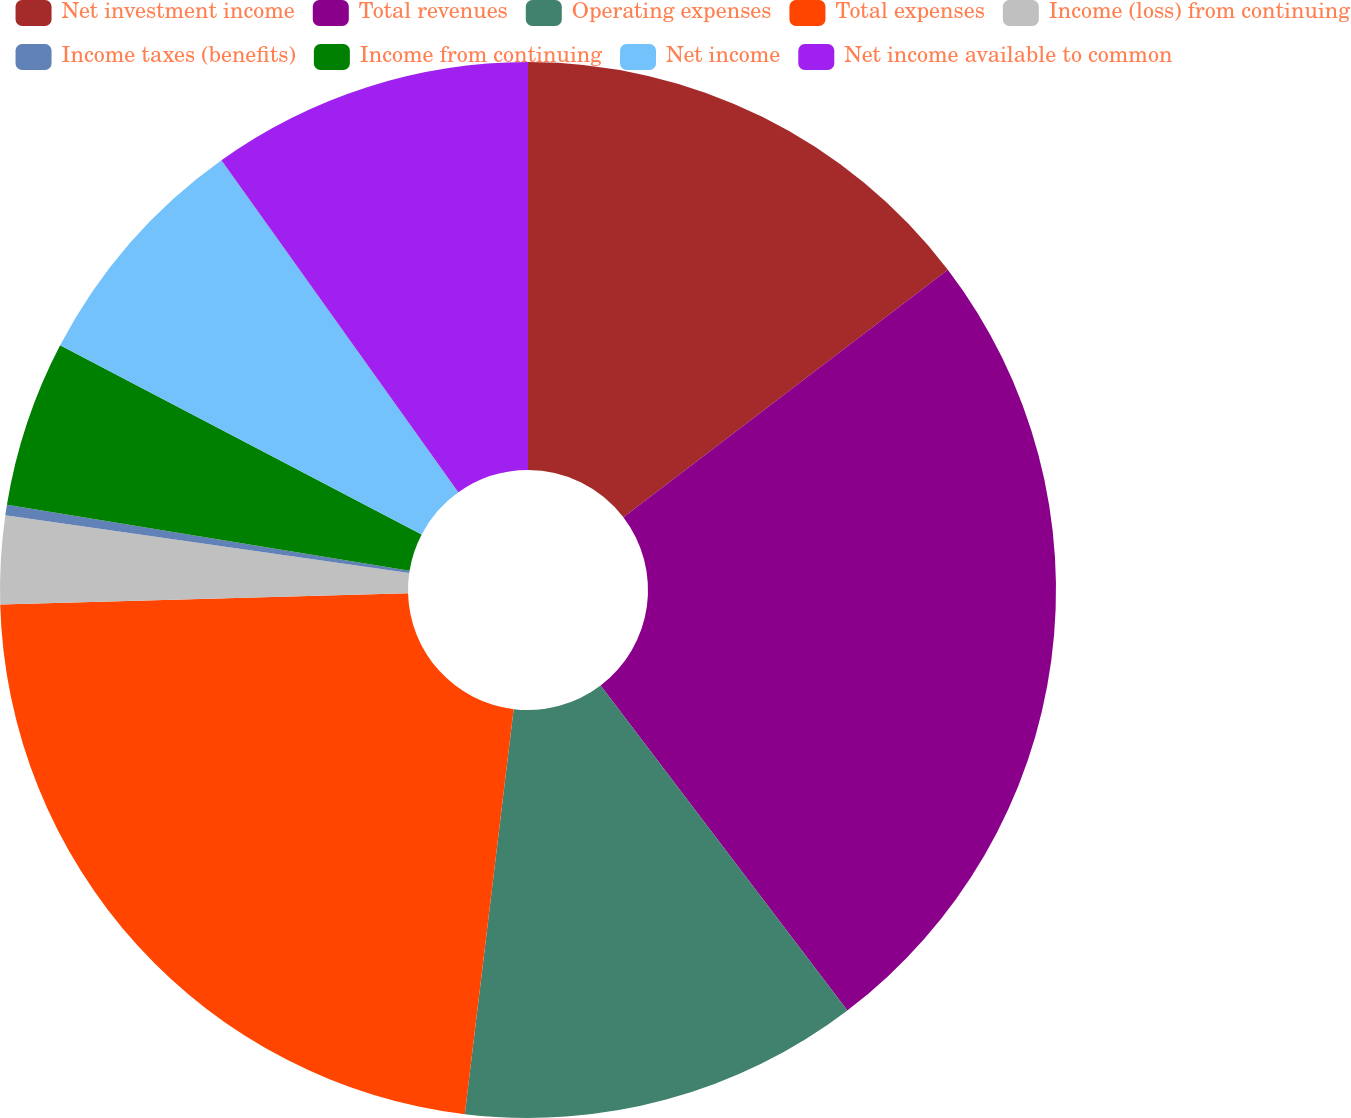Convert chart to OTSL. <chart><loc_0><loc_0><loc_500><loc_500><pie_chart><fcel>Net investment income<fcel>Total revenues<fcel>Operating expenses<fcel>Total expenses<fcel>Income (loss) from continuing<fcel>Income taxes (benefits)<fcel>Income from continuing<fcel>Net income<fcel>Net income available to common<nl><fcel>14.63%<fcel>25.03%<fcel>12.25%<fcel>22.65%<fcel>2.7%<fcel>0.32%<fcel>5.09%<fcel>7.47%<fcel>9.86%<nl></chart> 